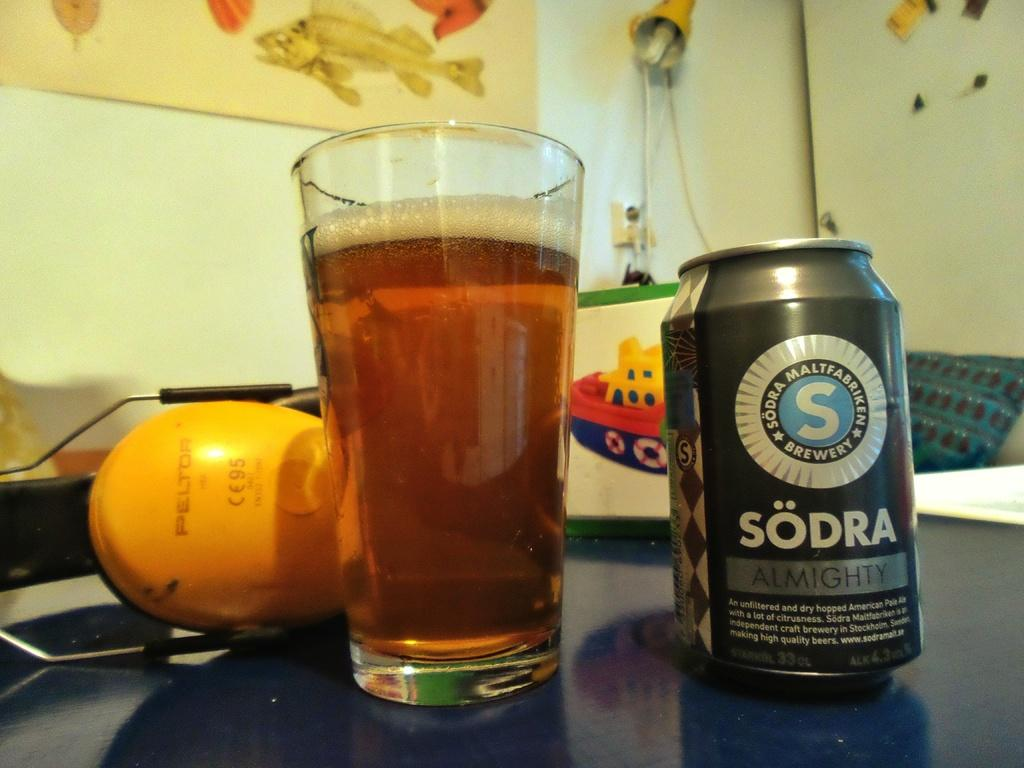<image>
Relay a brief, clear account of the picture shown. A can of Sodra is next to a full glass. 